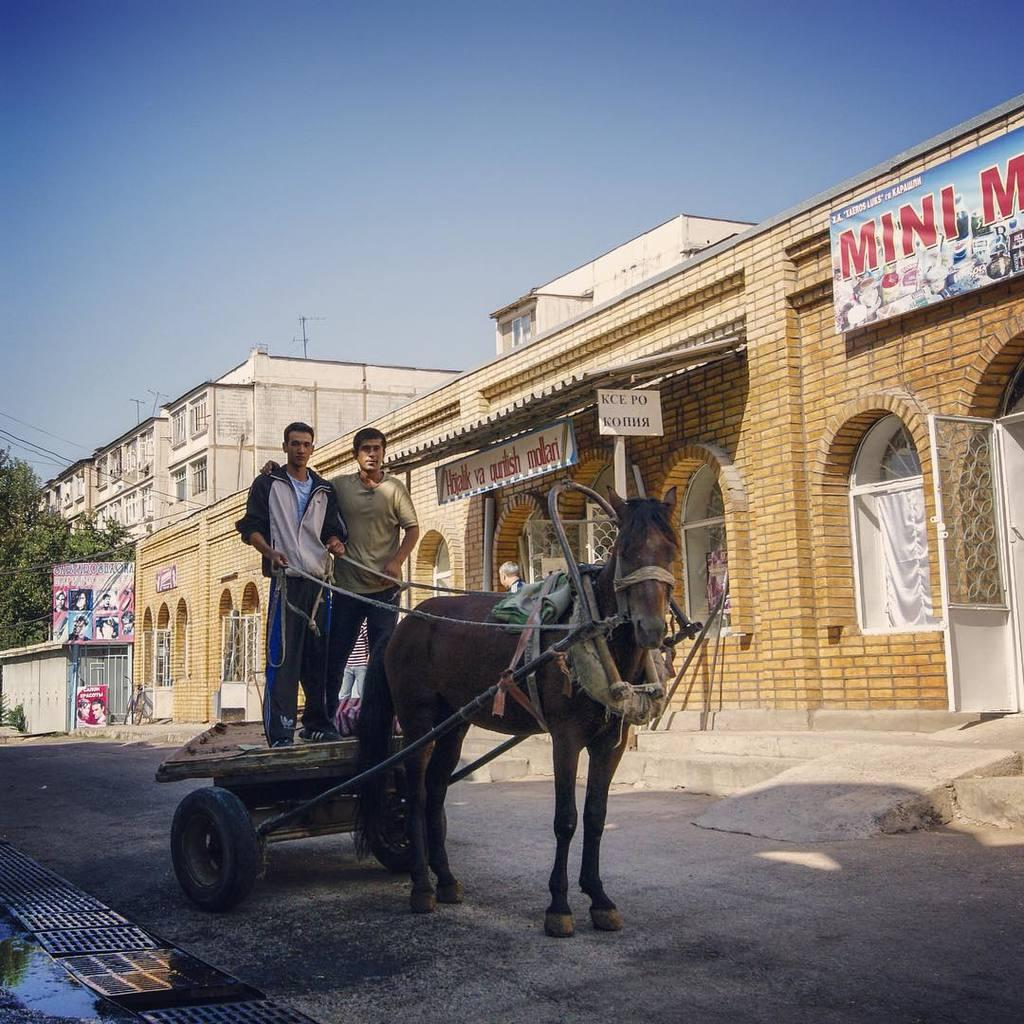What animal is present in the image? There is a horse in the image. How many people are in the image? There are two people standing in the image. What structures can be seen in the image? There are buildings in the image. What additional feature is present in the image? There is a banner in the image. What type of vegetation is visible in the image? There are trees in the image. What is visible at the top of the image? The sky is visible at the top of the image. How many fish can be seen swimming in the image? There are no fish present in the image. What type of coat is the horse wearing in the image? The horse is not wearing a coat in the image; it is a horse without any clothing. 